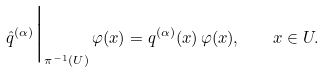<formula> <loc_0><loc_0><loc_500><loc_500>\hat { q } ^ { ( \alpha ) } \Big | _ { \pi ^ { - 1 } ( U ) } \, \varphi ( x ) = q ^ { ( \alpha ) } ( x ) \, \varphi ( x ) , \quad x \in U .</formula> 